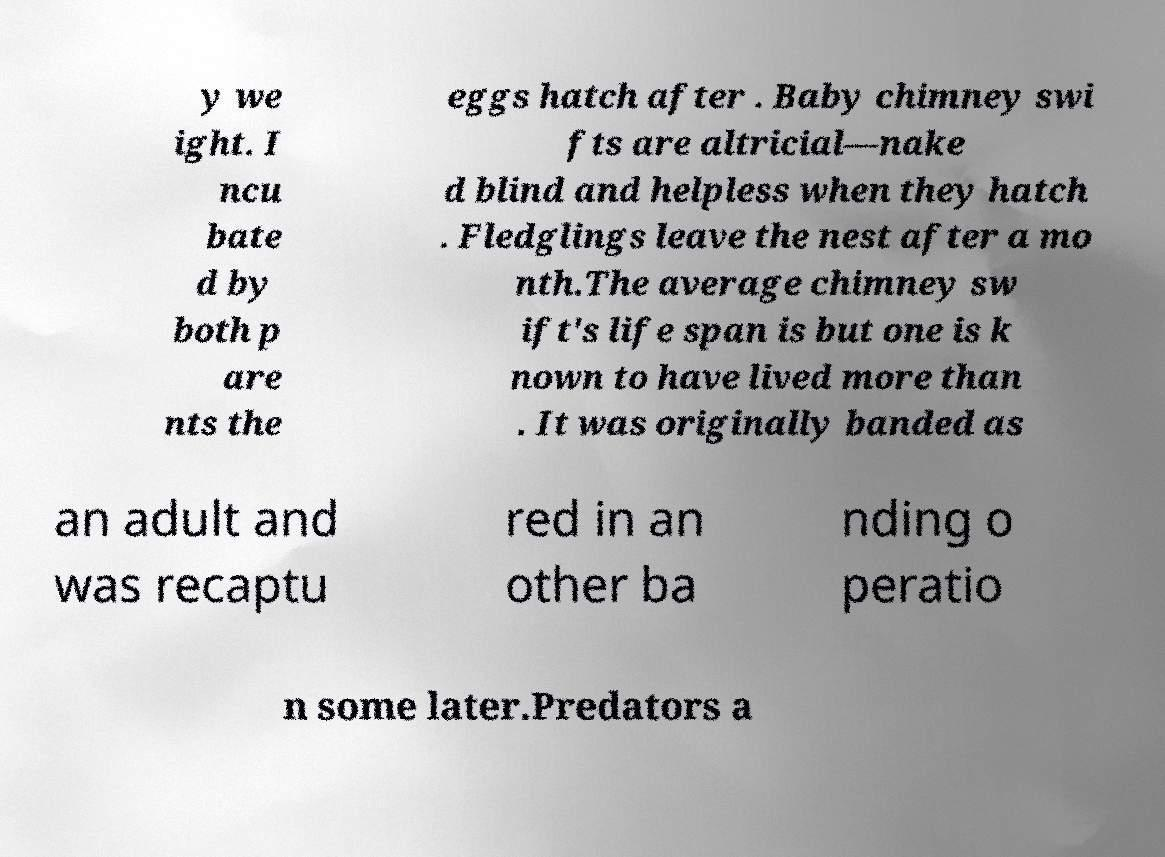Please identify and transcribe the text found in this image. y we ight. I ncu bate d by both p are nts the eggs hatch after . Baby chimney swi fts are altricial—nake d blind and helpless when they hatch . Fledglings leave the nest after a mo nth.The average chimney sw ift's life span is but one is k nown to have lived more than . It was originally banded as an adult and was recaptu red in an other ba nding o peratio n some later.Predators a 